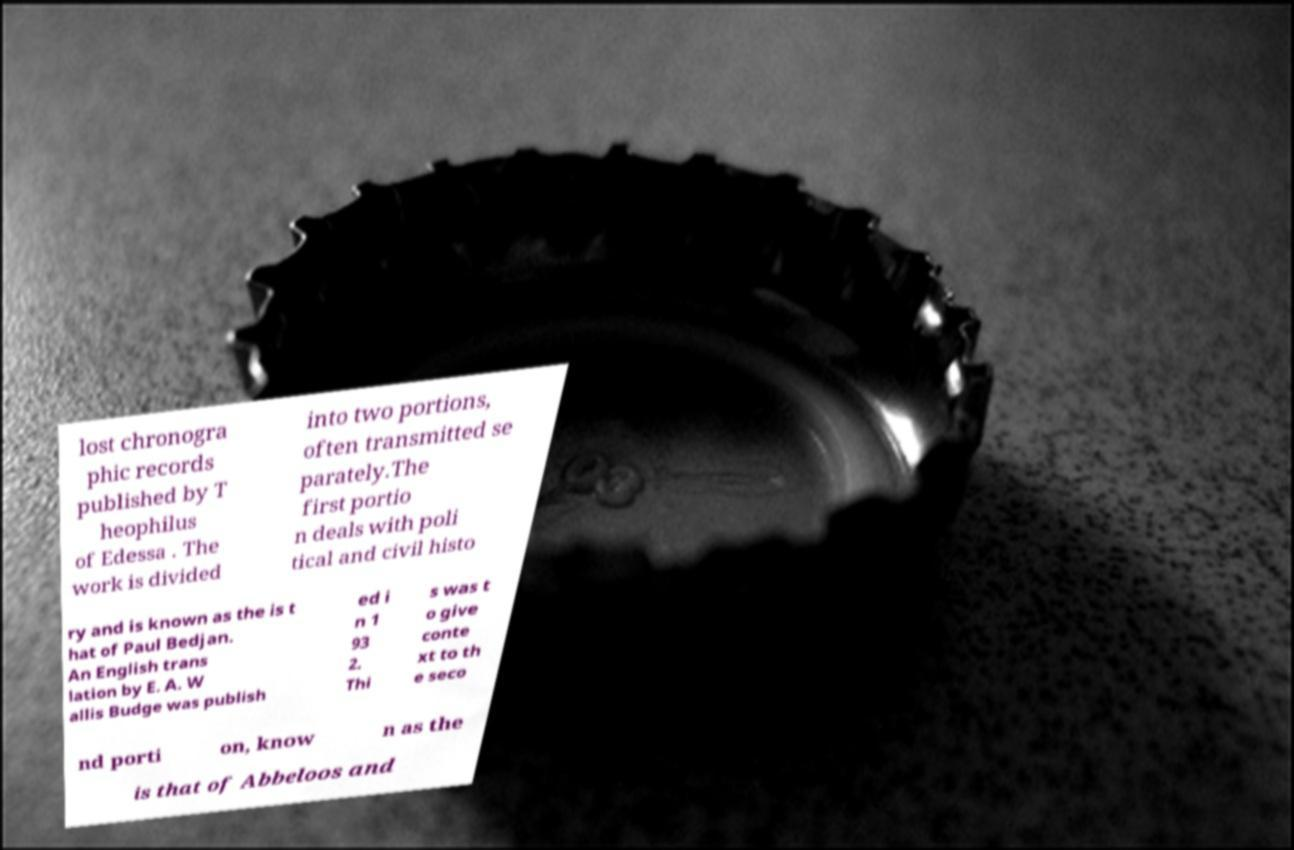Please identify and transcribe the text found in this image. lost chronogra phic records published by T heophilus of Edessa . The work is divided into two portions, often transmitted se parately.The first portio n deals with poli tical and civil histo ry and is known as the is t hat of Paul Bedjan. An English trans lation by E. A. W allis Budge was publish ed i n 1 93 2. Thi s was t o give conte xt to th e seco nd porti on, know n as the is that of Abbeloos and 